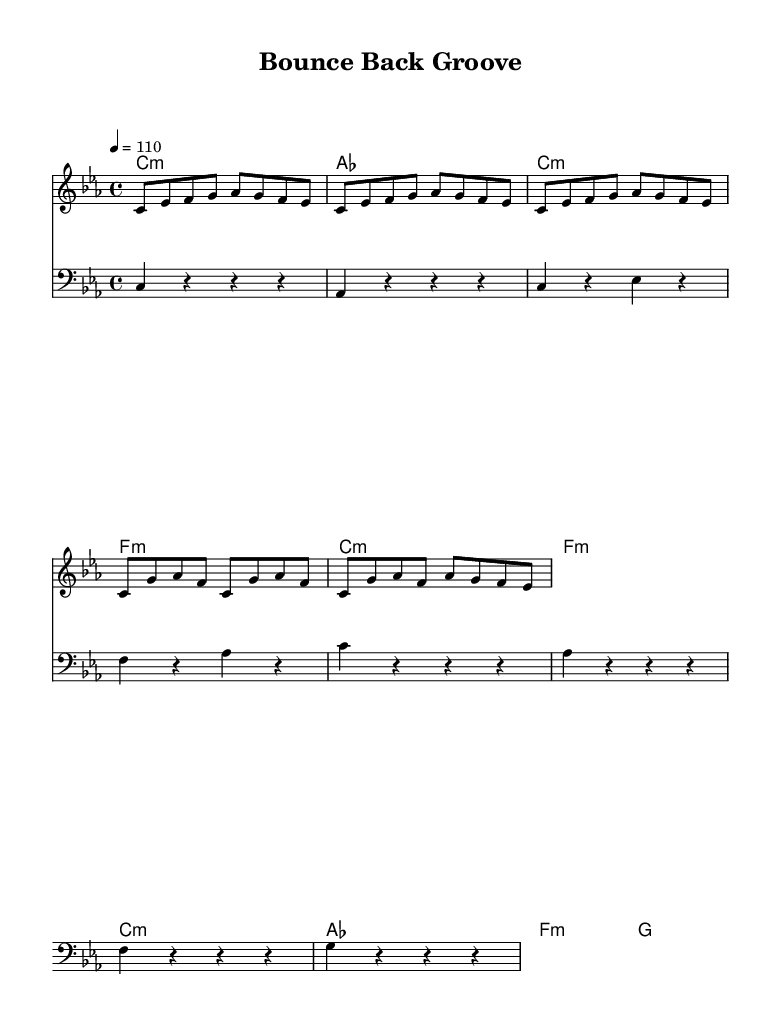What is the key signature of this music? The key signature is C minor, which has three flats (B, E, and A). This is indicated at the beginning of the sheet music.
Answer: C minor What is the time signature of the piece? The time signature is 4/4, which means there are four beats in each measure and the quarter note gets one beat. This is shown at the start of the score.
Answer: 4/4 What is the tempo marking? The tempo marking is 110 BPM (beats per minute), indicating how fast the piece should be played. This is found at the beginning of the score.
Answer: 110 How many measures are there in the melody section? There are twelve measures in the melody section, counted by looking at the number of vertical lines that separate the measures.
Answer: 12 What is the chord progression for the chorus? The chord progression for the chorus is C minor, A flat, F minor, G. This is determined by examining the chord symbols provided above the melody during the chorus sections.
Answer: C minor, A flat, F minor, G What mood does the lyrical content convey? The lyrical content conveys a theme of resilience and personal growth, as indicated by phrases like "Bounce back, stronger than before." This is derived from the lyrics associated with the music.
Answer: Resilience 